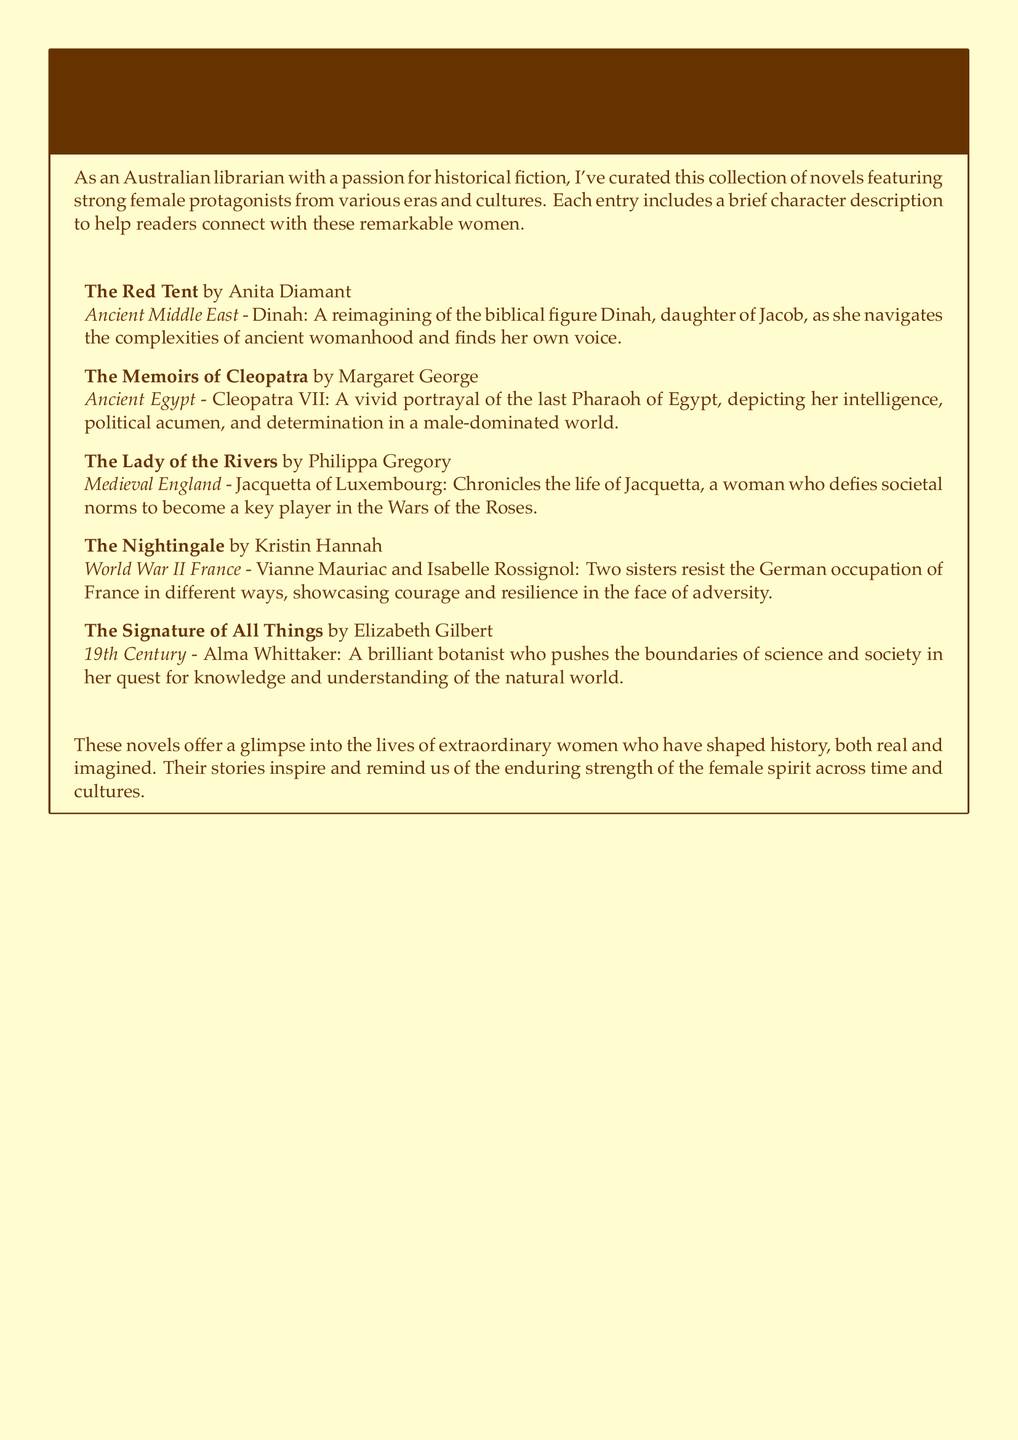What is the title of the first novel? The first novel listed in the catalog is "The Red Tent."
Answer: The Red Tent Who is the protagonist in "The Nightingale"? The protagonists in "The Nightingale" are Vianne Mauriac and Isabelle Rossignol.
Answer: Vianne Mauriac and Isabelle Rossignol Which novel features a character from Ancient Egypt? The novel "The Memoirs of Cleopatra" features a character from Ancient Egypt.
Answer: The Memoirs of Cleopatra What era does "The Signature of All Things" belong to? "The Signature of All Things" is set in the 19th Century.
Answer: 19th Century How many protagonists are featured in "The Nightingale"? "The Nightingale" features two protagonists.
Answer: Two Which author wrote about a character named Jacquetta of Luxembourg? Philippa Gregory wrote about Jacquetta of Luxembourg in "The Lady of the Rivers."
Answer: Philippa Gregory What is the overarching theme of the novels listed in the catalog? The theme revolves around strong female protagonists and their impact throughout history.
Answer: Strong female protagonists In what context does Alma Whittaker operate in "The Signature of All Things"? Alma Whittaker operates in the context of pushing the boundaries of science and society.
Answer: Science and society 